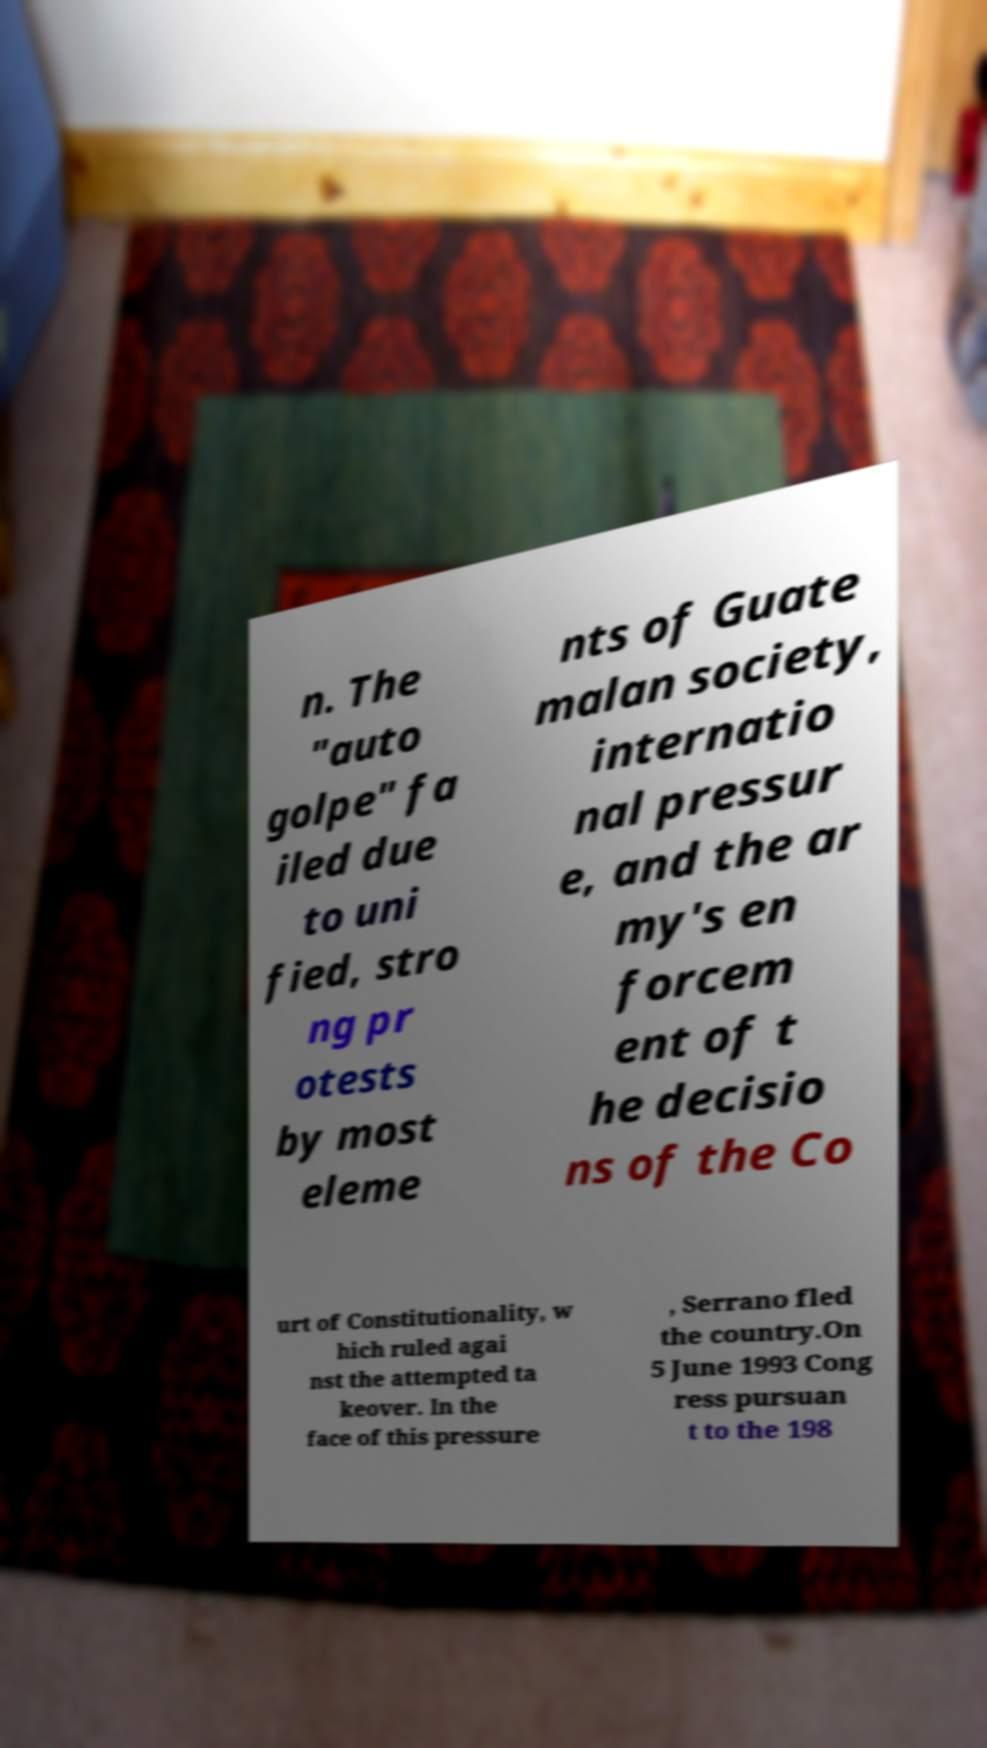What messages or text are displayed in this image? I need them in a readable, typed format. n. The "auto golpe" fa iled due to uni fied, stro ng pr otests by most eleme nts of Guate malan society, internatio nal pressur e, and the ar my's en forcem ent of t he decisio ns of the Co urt of Constitutionality, w hich ruled agai nst the attempted ta keover. In the face of this pressure , Serrano fled the country.On 5 June 1993 Cong ress pursuan t to the 198 